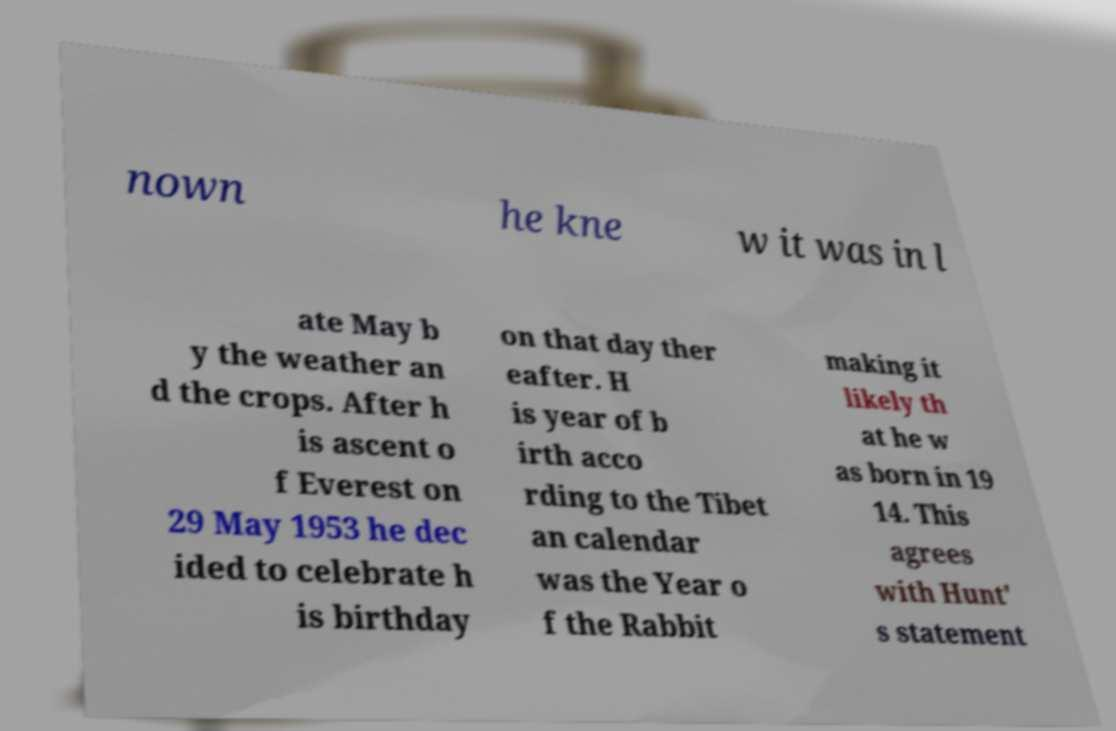There's text embedded in this image that I need extracted. Can you transcribe it verbatim? nown he kne w it was in l ate May b y the weather an d the crops. After h is ascent o f Everest on 29 May 1953 he dec ided to celebrate h is birthday on that day ther eafter. H is year of b irth acco rding to the Tibet an calendar was the Year o f the Rabbit making it likely th at he w as born in 19 14. This agrees with Hunt' s statement 